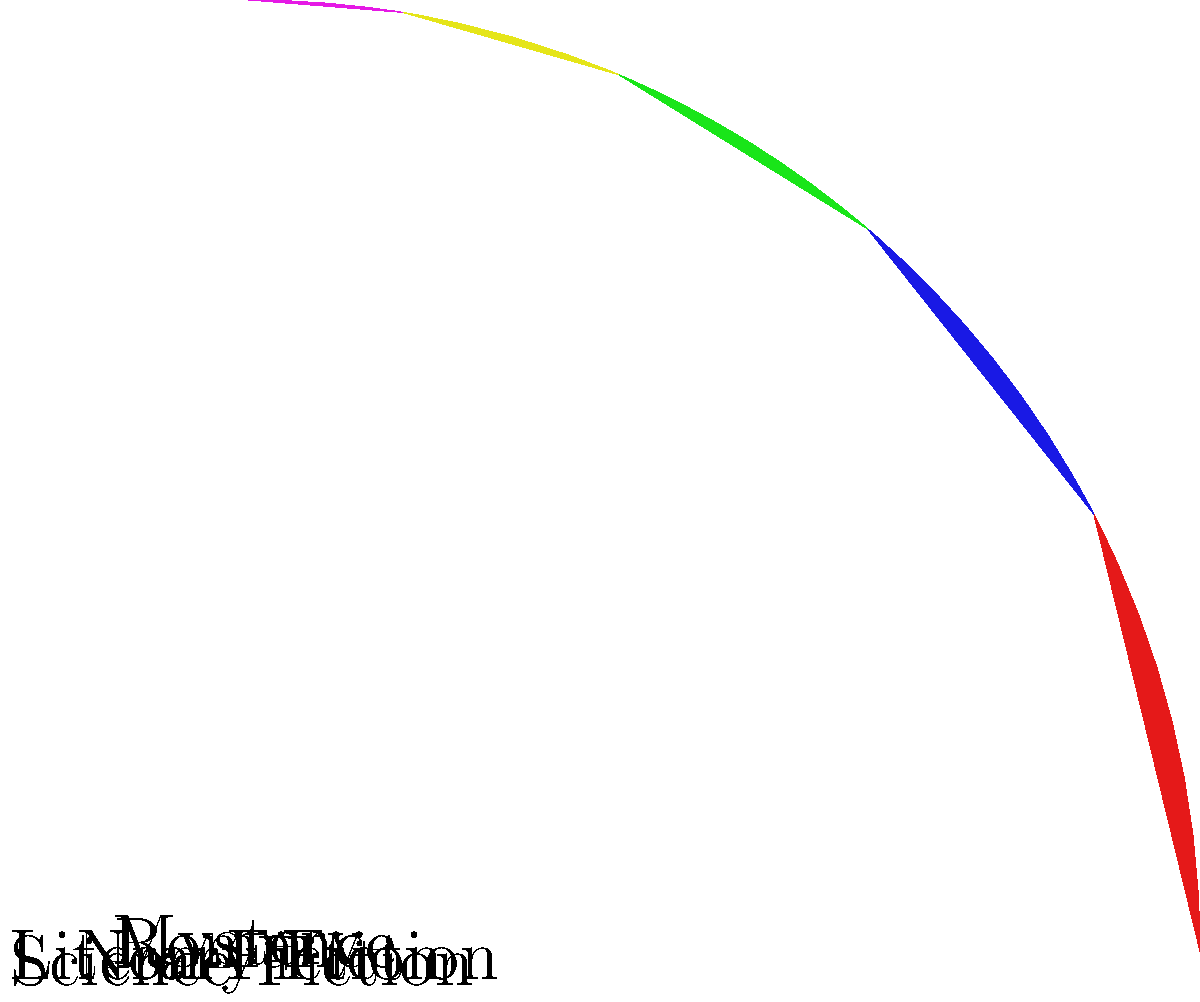As a novelist who appreciates the nuances of literary genres, analyze the pie chart depicting book cover design classifications. Which genre, often associated with speculative futures and technological advancements, comprises 20% of the dataset? To answer this question, we need to follow these steps:

1. Examine the pie chart carefully, noting the different genres and their respective percentages.

2. Identify the slice that represents 20% of the total:
   - Romance: 30%
   - Mystery: 25%
   - Science Fiction: 20%
   - Literary Fiction: 15%
   - Non-Fiction: 10%

3. Recognize that Science Fiction is the genre that comprises 20% of the dataset.

4. Consider the characteristics of Science Fiction:
   - Often deals with speculative futures
   - Frequently involves technological advancements
   - Explores the potential consequences of scientific innovations

5. Reflect on how these themes align with the description in the question: "often associated with speculative futures and technological advancements."

6. Conclude that Science Fiction is the correct answer, as it matches both the percentage and the thematic description provided in the question.
Answer: Science Fiction 